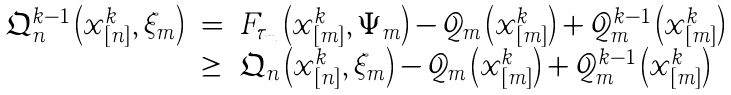<formula> <loc_0><loc_0><loc_500><loc_500>\begin{array} { l l l } \mathfrak { Q } _ { n } ^ { k - 1 } \left ( x _ { [ n ] } ^ { k } , \xi _ { m } \right ) & = & F _ { \tau _ { m } } \left ( x _ { [ m ] } ^ { k } , \Psi _ { m } \right ) - \mathcal { Q } _ { m } \left ( x _ { [ m ] } ^ { k } \right ) + \mathcal { Q } _ { m } ^ { k - 1 } \left ( x _ { [ m ] } ^ { k } \right ) \\ & \geq & \mathfrak { Q } _ { n } \left ( x _ { [ n ] } ^ { k } , \xi _ { m } \right ) - \mathcal { Q } _ { m } \left ( x _ { [ m ] } ^ { k } \right ) + \mathcal { Q } _ { m } ^ { k - 1 } \left ( x _ { [ m ] } ^ { k } \right ) \end{array}</formula> 